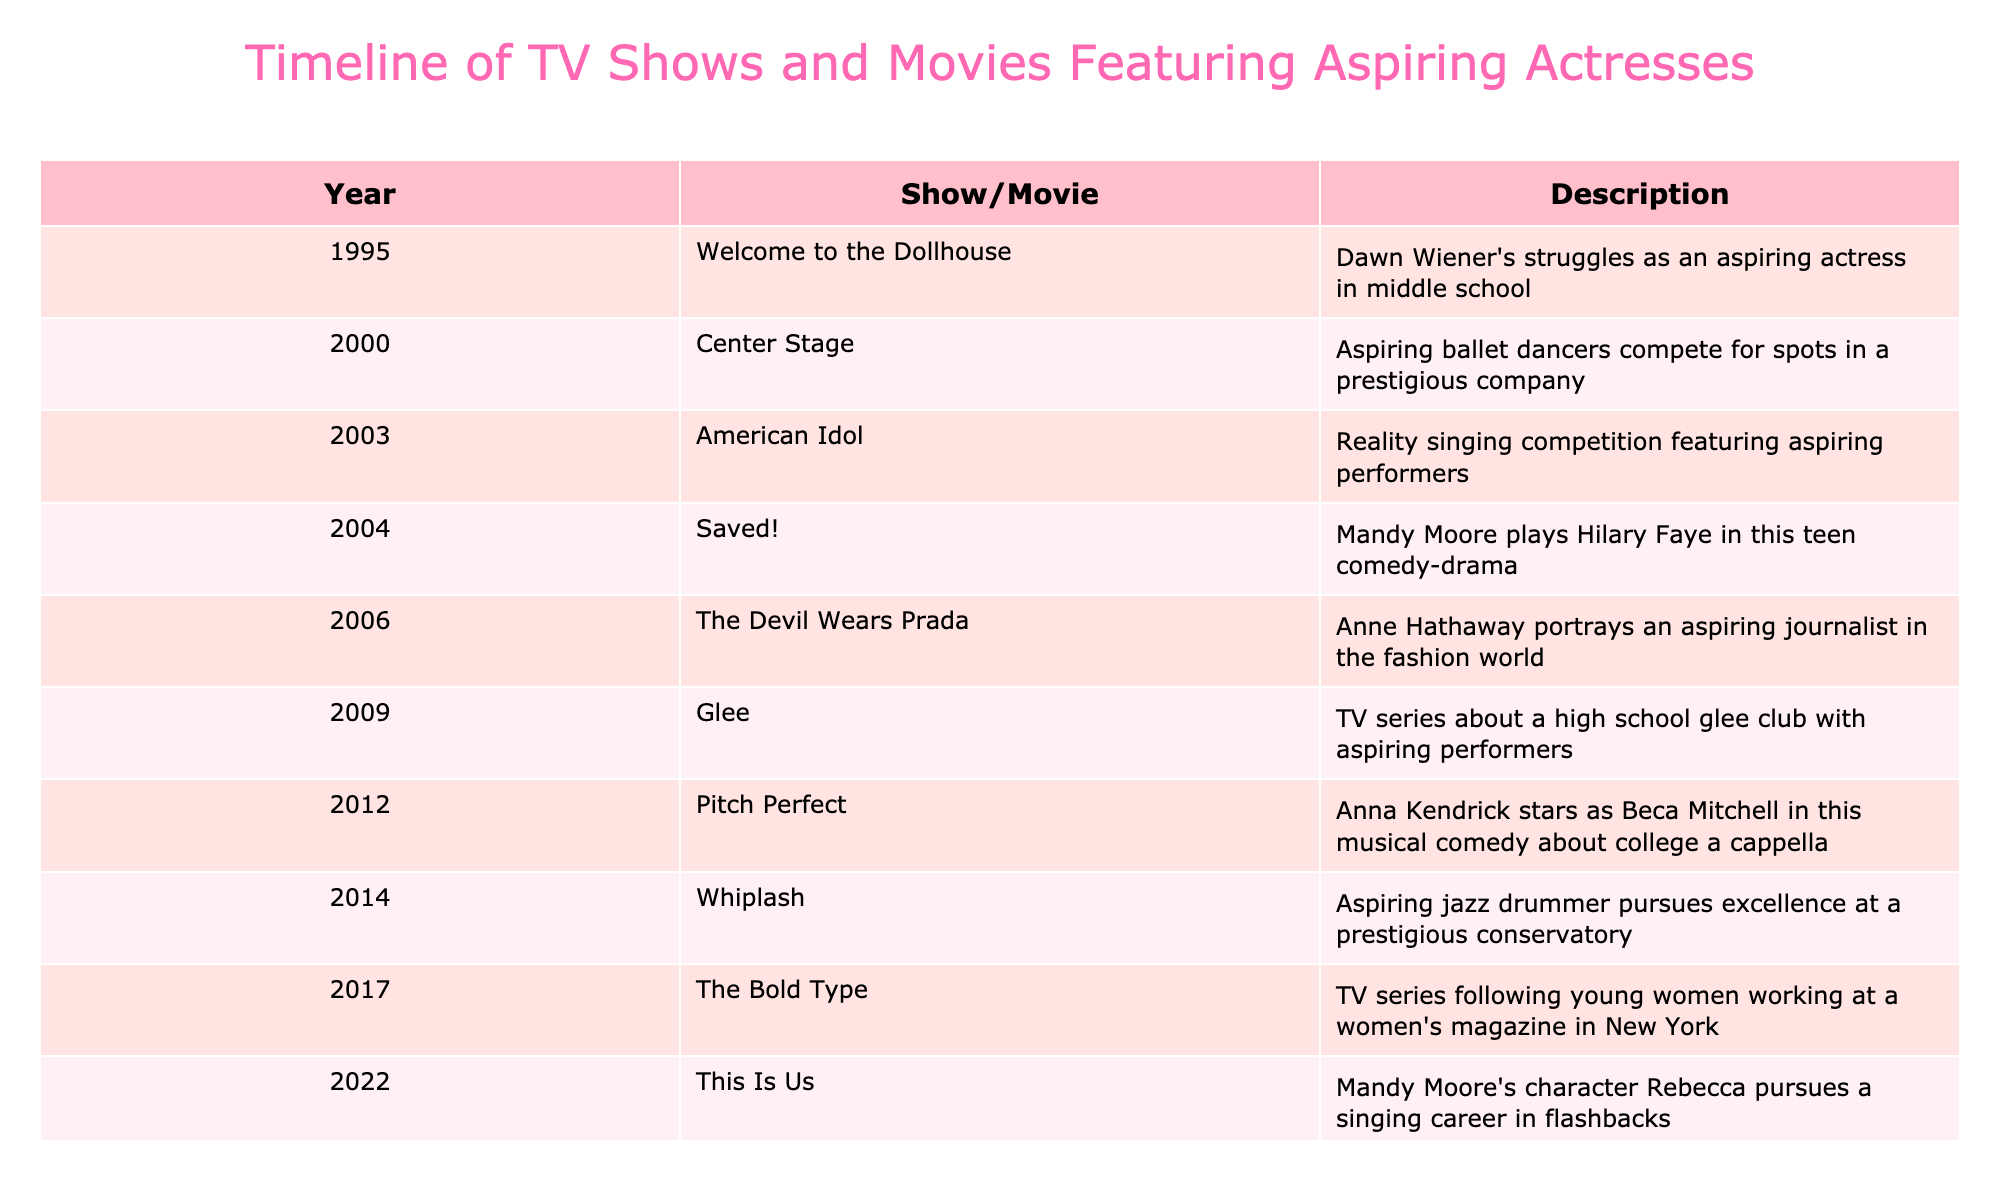What year did "Center Stage" release? The title "Center Stage" is listed in the table under the Show/Movie column. By locating it, I see that it corresponds to the year 2000 in the Year column.
Answer: 2000 Which show features Mandy Moore? In the table, I check the Show/Movie column for entries that mention Mandy Moore. The entry "Saved!" from 2004 lists Mandy Moore's character Hilary Faye, confirming that she is featured in this movie.
Answer: "Saved!" How many different shows or movies are listed from the year 2012? Referring to the table, I look for entries under the year 2012. The table has only one entry for this year, which is "Pitch Perfect." Therefore, the count is 1.
Answer: 1 Did "Glee" feature aspiring dancers? In the table, "Glee" is listed in 2009 and describes a TV series focused on a high school glee club with aspiring performers, but it does not specifically mention dancers. Thus, the answer is no.
Answer: No What is the average year of release for these shows/movies? To find the average, I sum the years: (1995 + 2000 + 2003 + 2004 + 2006 + 2009 + 2012 + 2014 + 2017 + 2022 + 2023) = 2207. There are 11 entries. Then, I divide 2207 by 11, resulting in approximately 200.64, which rounds to 201.
Answer: 201 How many entries are from the 2000s decade? I count the rows for the years that fall within the 2000s (2000-2009) in the table. The years listed for the 2000s are 2000, 2003, 2004, 2006, and 2009, making a total of 5 entries.
Answer: 5 In which show did Anne Hathaway portray an aspiring journalist? The table shows that "The Devil Wears Prada" from 2006 features Anne Hathaway in this role. By cross-referencing the description, I confirm that it corresponds to an aspiring journalist.
Answer: "The Devil Wears Prada" Is "American Idol" a movie or a TV show? Checking the Show/Movie column and its description for "American Idol", it identifies as a reality singing competition, which categorizes it as a TV show. Therefore, the answer is yes.
Answer: Yes Which year had the most recent entry in the table? Looking at the Years column, the latest entry listed is 2023, which corresponds to "Daisy Jones & The Six." This indicates that 2023 is the most recent year in the table.
Answer: 2023 